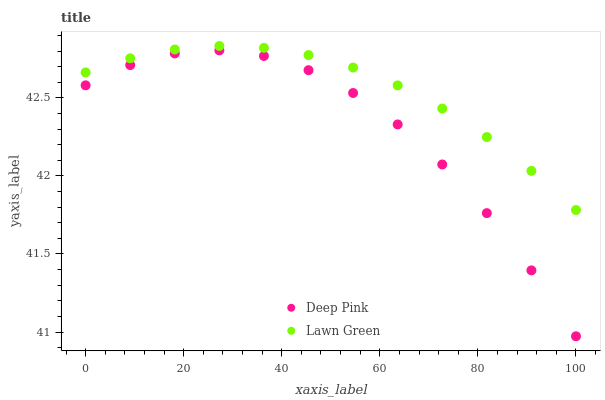Does Deep Pink have the minimum area under the curve?
Answer yes or no. Yes. Does Lawn Green have the maximum area under the curve?
Answer yes or no. Yes. Does Deep Pink have the maximum area under the curve?
Answer yes or no. No. Is Lawn Green the smoothest?
Answer yes or no. Yes. Is Deep Pink the roughest?
Answer yes or no. Yes. Is Deep Pink the smoothest?
Answer yes or no. No. Does Deep Pink have the lowest value?
Answer yes or no. Yes. Does Lawn Green have the highest value?
Answer yes or no. Yes. Does Deep Pink have the highest value?
Answer yes or no. No. Is Deep Pink less than Lawn Green?
Answer yes or no. Yes. Is Lawn Green greater than Deep Pink?
Answer yes or no. Yes. Does Deep Pink intersect Lawn Green?
Answer yes or no. No. 